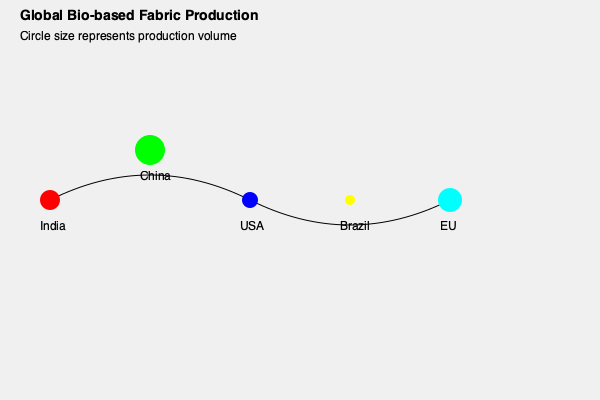Based on the world map representation of bio-based fabric production, which country or region appears to have the largest production volume, and what implications might this have for global sustainability initiatives in the fashion industry? To answer this question, we need to analyze the information provided in the world map representation:

1. The map shows five main regions/countries: India, China, USA, Brazil, and EU.
2. The size of the circles represents the production volume of bio-based fabrics.
3. Comparing the sizes of the circles:
   - China has the largest circle, indicating the highest production volume.
   - India and EU have the next largest circles, suggesting significant production.
   - USA has a smaller circle, indicating moderate production.
   - Brazil has the smallest circle, suggesting the lowest production volume among the represented regions.

4. Implications for global sustainability initiatives in the fashion industry:
   a) China's leadership in production volume could mean:
      - Greater potential for scaling up sustainable practices
      - Significant impact on global supply chains
      - Opportunity for setting industry standards
   b) The distribution across multiple regions suggests:
      - Diverse sourcing options for sustainable fabrics
      - Need for international cooperation in sustainability efforts
   c) Smaller producers like Brazil may:
      - Offer unique, specialized bio-based fabrics
      - Require support to increase production and competitiveness

5. As a sustainability policy advisor, this information could inform:
   - Targeted collaborations with major producers like China
   - Strategies for supporting and developing production in smaller markets
   - Policy recommendations for balancing production across regions to ensure resilience and diversity in sustainable fabric supply

Therefore, China appears to have the largest production volume of bio-based fabrics, which has significant implications for shaping global sustainability initiatives in the fashion industry.
Answer: China; largest production volume implies potential for setting industry standards and significant impact on global sustainability initiatives. 